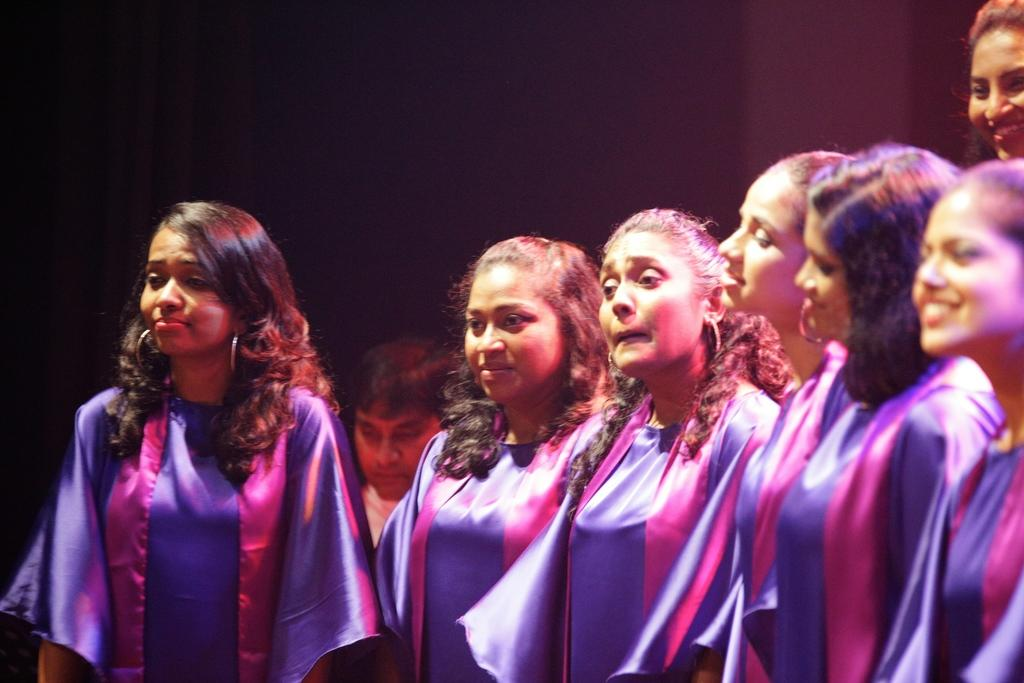What is the main subject of the image? The main subject of the image is women standing together. What are the women in the front wearing? The six women in the front are wearing graduation gowns. What can be observed about the background of the image? The background of the image is dark. How many rabbits can be seen in the image? There are no rabbits present in the image. What part of the brain is responsible for the organization of the women in the image? The image does not provide information about the women's organization or the brain's involvement in it. 